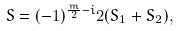Convert formula to latex. <formula><loc_0><loc_0><loc_500><loc_500>S = ( - 1 ) ^ { \frac { m } { 2 } - i } 2 ( S _ { 1 } + S _ { 2 } ) ,</formula> 